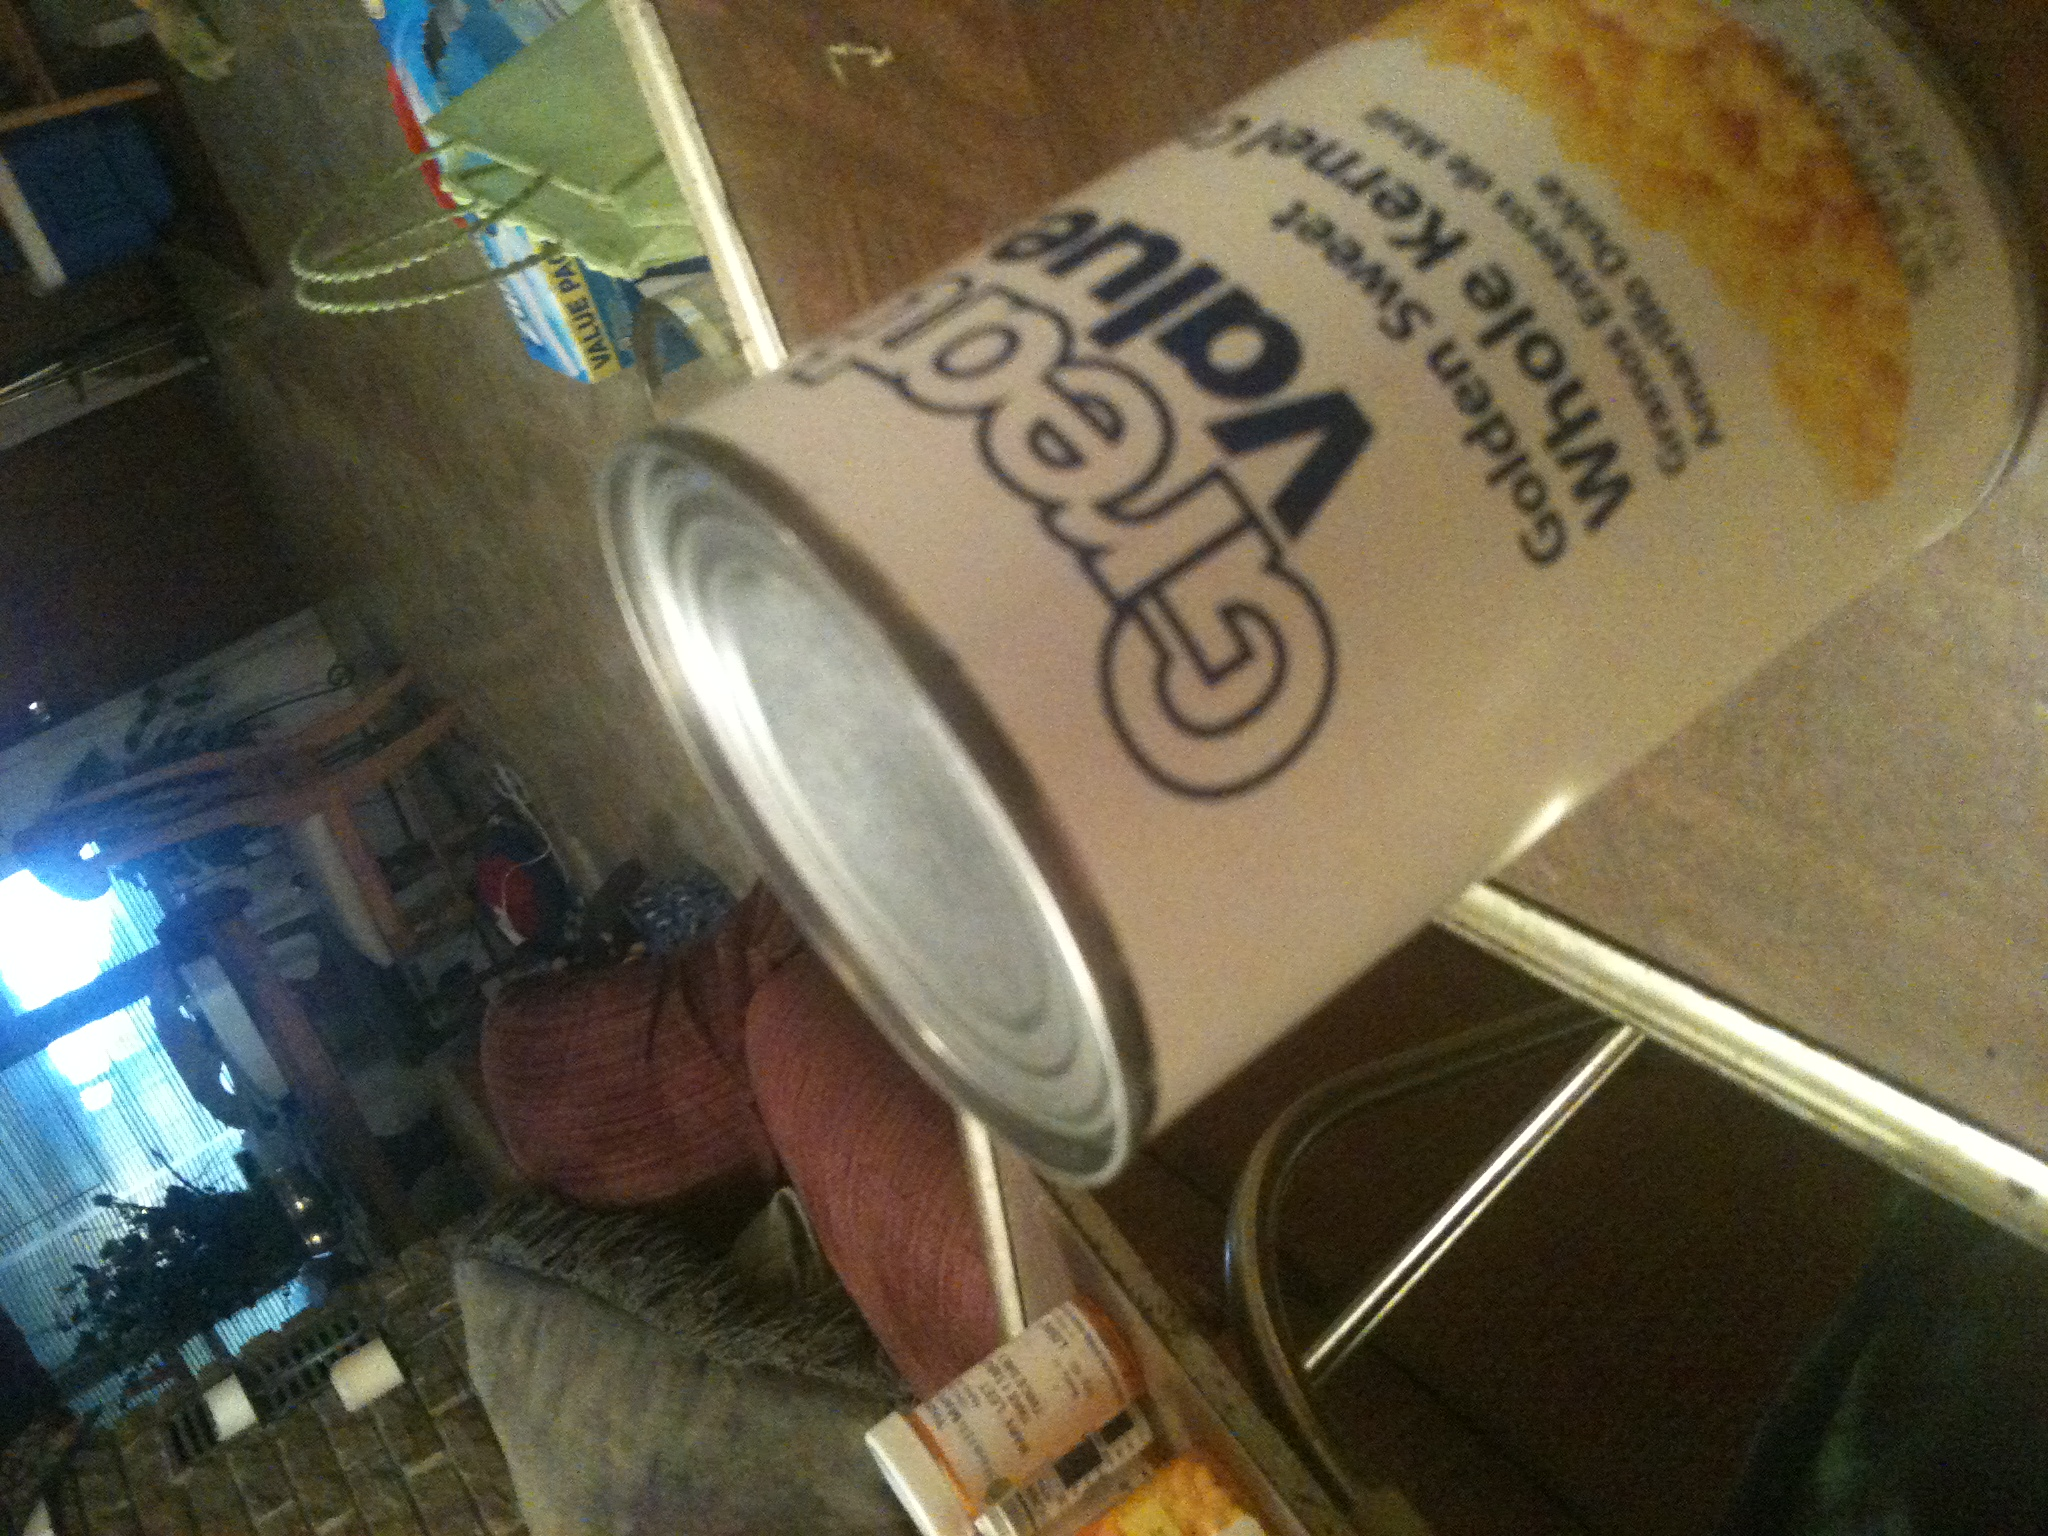What nutritional benefits does sweet corn provide? Sweet corn is packed with beneficial nutrients! It's a good source of dietary fiber, which aids digestion. Corn is also rich in vitamin C, which supports the immune system, and provides B vitamins, essential for energy production. Plus, corn contains antioxidants like lutein and zeaxanthin, which are excellent for eye health. 